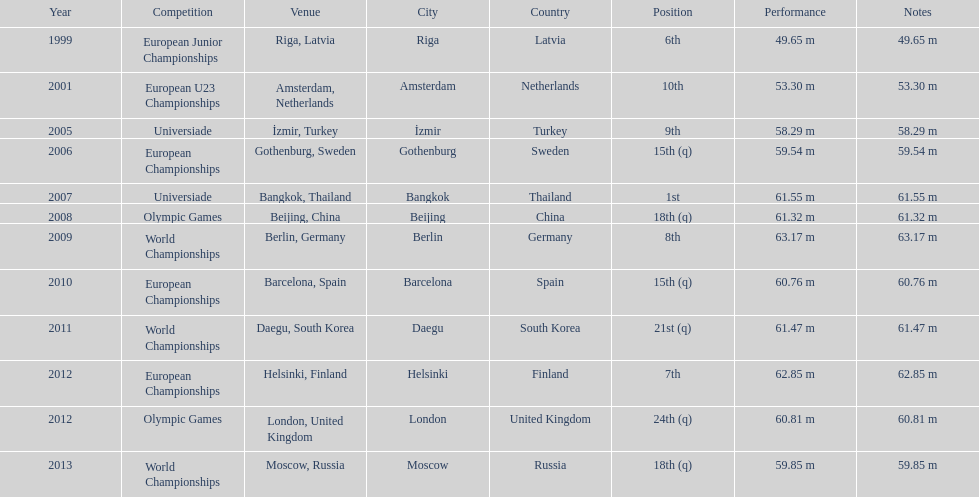What is the total number of world championships he has competed in? 3. 